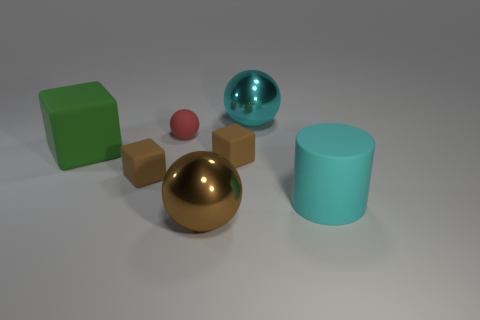There is a metallic thing in front of the big thing that is left of the brown sphere; what shape is it?
Keep it short and to the point. Sphere. Is there another large brown thing that has the same shape as the large brown object?
Offer a very short reply. No. Do the small ball and the shiny ball behind the large green cube have the same color?
Your answer should be very brief. No. There is a metal thing that is the same color as the big matte cylinder; what is its size?
Your answer should be very brief. Large. Is there another ball of the same size as the red ball?
Your answer should be compact. No. Do the small sphere and the small brown object that is on the left side of the large brown ball have the same material?
Keep it short and to the point. Yes. Is the number of cyan metal things greater than the number of tiny brown objects?
Your answer should be compact. No. How many blocks are either matte things or big green objects?
Your response must be concise. 3. The rubber cylinder has what color?
Keep it short and to the point. Cyan. Is the size of the shiny sphere that is behind the cyan matte object the same as the cyan thing on the right side of the big cyan shiny thing?
Ensure brevity in your answer.  Yes. 